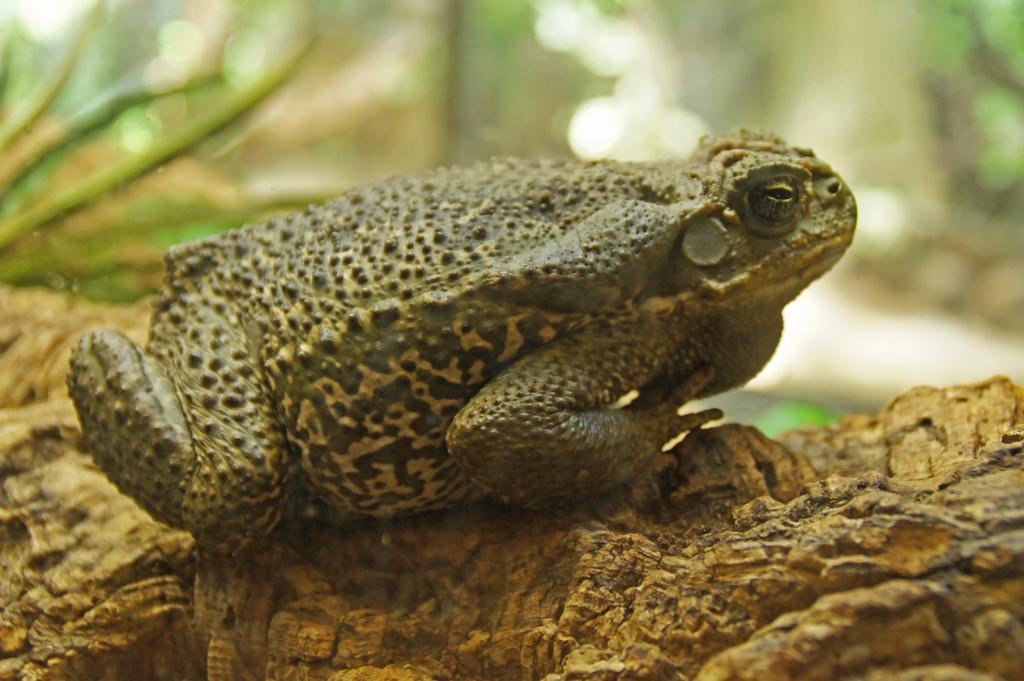What animal is present in the image? There is a frog in the image. Where is the frog located? The frog is on the ground. What can be seen in the background of the image? There are plants visible in the background of the image. What type of suit is the frog wearing in the image? There is no suit present in the image, as the frog is an amphibian and does not wear clothing. 